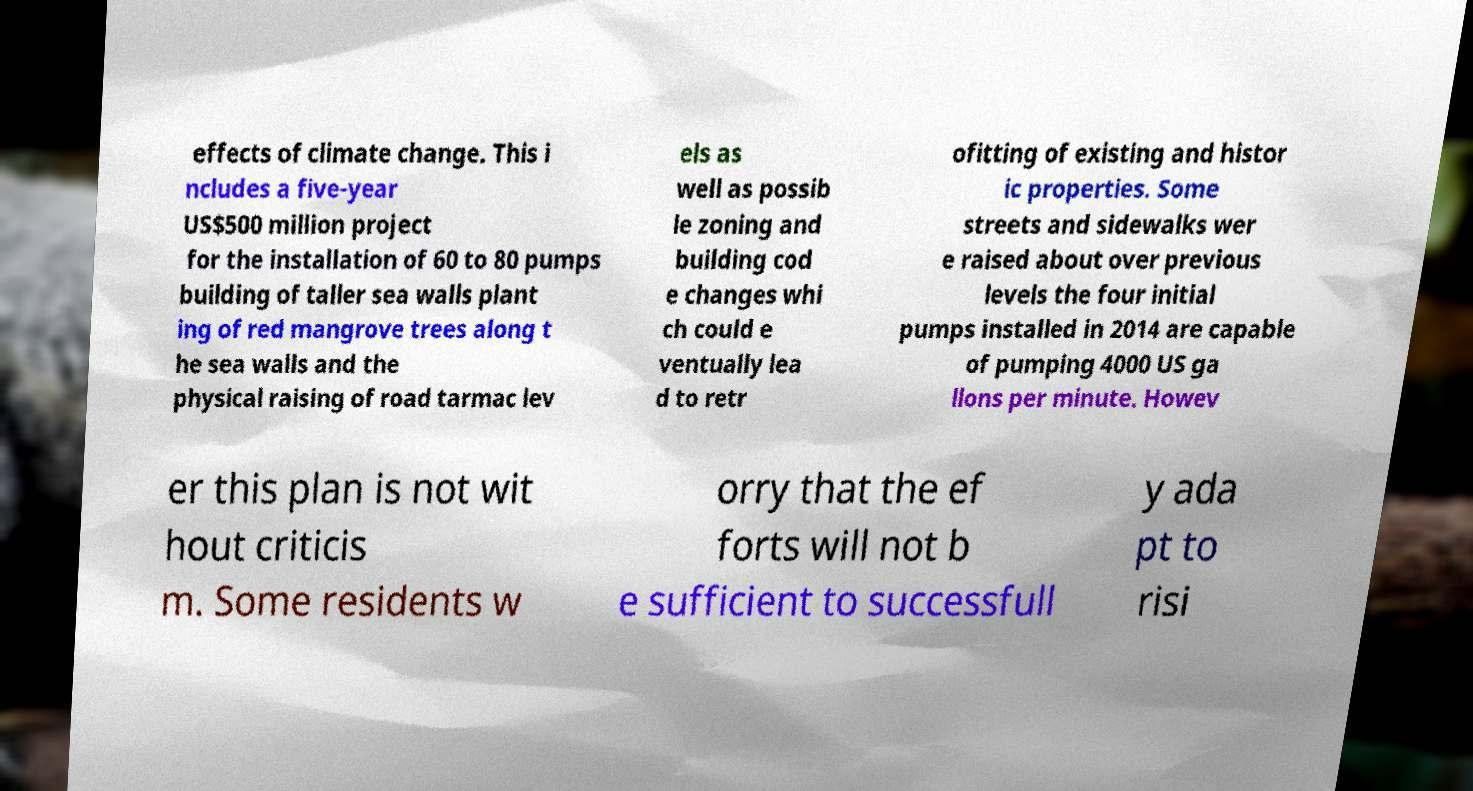Can you accurately transcribe the text from the provided image for me? effects of climate change. This i ncludes a five-year US$500 million project for the installation of 60 to 80 pumps building of taller sea walls plant ing of red mangrove trees along t he sea walls and the physical raising of road tarmac lev els as well as possib le zoning and building cod e changes whi ch could e ventually lea d to retr ofitting of existing and histor ic properties. Some streets and sidewalks wer e raised about over previous levels the four initial pumps installed in 2014 are capable of pumping 4000 US ga llons per minute. Howev er this plan is not wit hout criticis m. Some residents w orry that the ef forts will not b e sufficient to successfull y ada pt to risi 